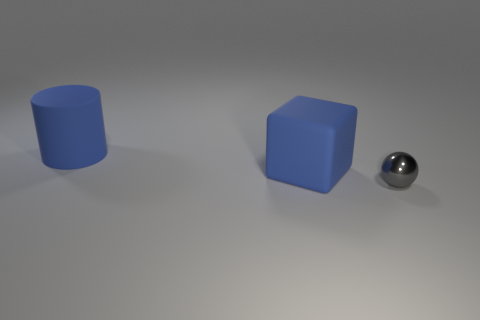Add 3 large cylinders. How many objects exist? 6 Subtract all cubes. How many objects are left? 2 Subtract all tiny gray objects. Subtract all small gray things. How many objects are left? 1 Add 1 gray objects. How many gray objects are left? 2 Add 1 big gray things. How many big gray things exist? 1 Subtract 0 gray cylinders. How many objects are left? 3 